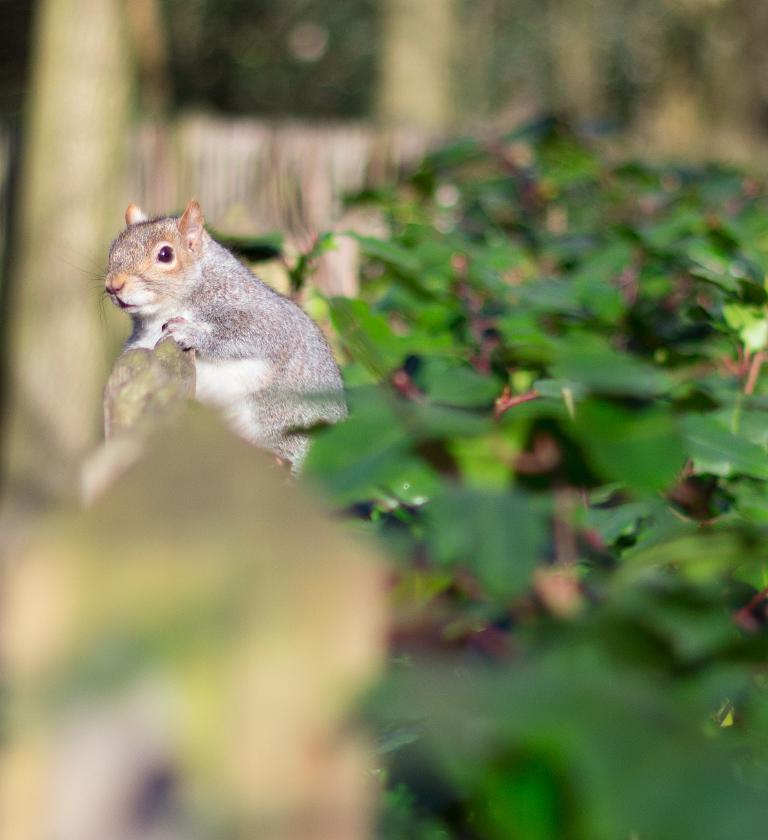Can you describe this image briefly? In the center of the image we can see a squirrel on some object. On the right side of the image, we can see leaves. In the background, we can see it is blurred. 